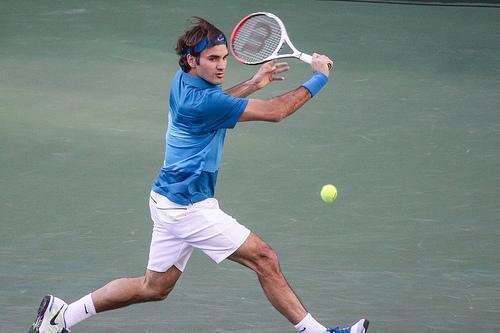How many players are seen?
Give a very brief answer. 1. How many stripes are in the man's shirt?
Give a very brief answer. 3. 